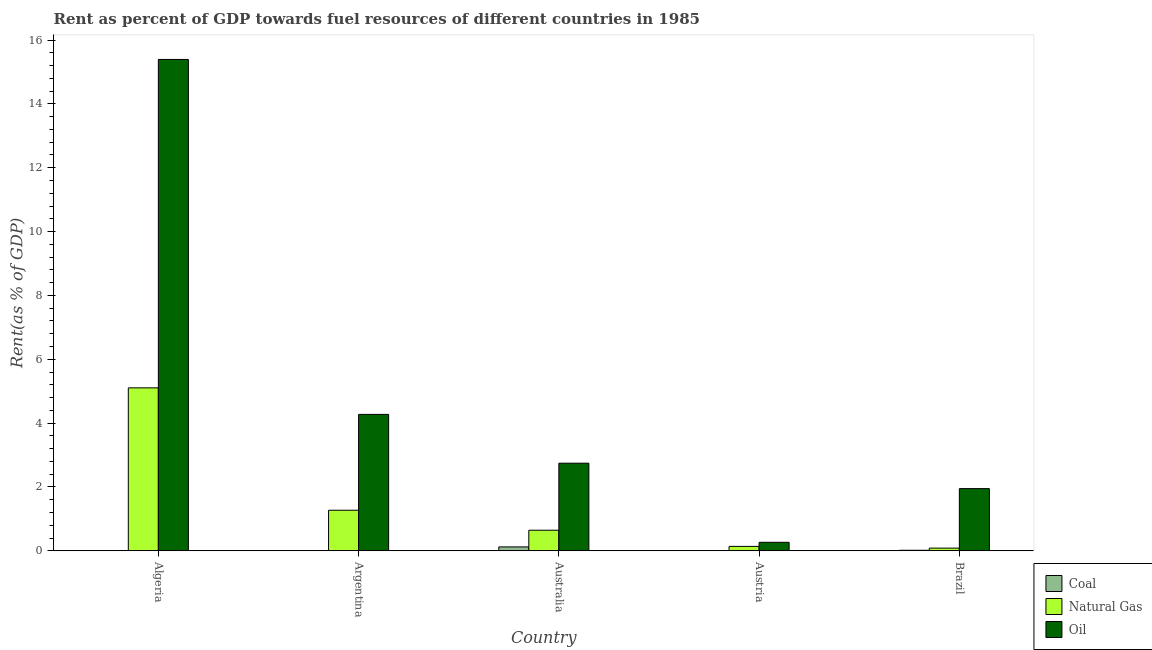How many different coloured bars are there?
Make the answer very short. 3. How many groups of bars are there?
Give a very brief answer. 5. Are the number of bars per tick equal to the number of legend labels?
Your response must be concise. Yes. How many bars are there on the 5th tick from the left?
Provide a short and direct response. 3. What is the rent towards natural gas in Algeria?
Offer a terse response. 5.1. Across all countries, what is the maximum rent towards natural gas?
Ensure brevity in your answer.  5.1. Across all countries, what is the minimum rent towards oil?
Make the answer very short. 0.27. In which country was the rent towards coal maximum?
Give a very brief answer. Australia. In which country was the rent towards coal minimum?
Your response must be concise. Algeria. What is the total rent towards coal in the graph?
Provide a succinct answer. 0.14. What is the difference between the rent towards oil in Argentina and that in Australia?
Offer a terse response. 1.53. What is the difference between the rent towards coal in Argentina and the rent towards natural gas in Brazil?
Provide a succinct answer. -0.08. What is the average rent towards coal per country?
Ensure brevity in your answer.  0.03. What is the difference between the rent towards coal and rent towards oil in Australia?
Give a very brief answer. -2.62. What is the ratio of the rent towards natural gas in Argentina to that in Brazil?
Make the answer very short. 15.24. Is the rent towards oil in Argentina less than that in Austria?
Offer a very short reply. No. Is the difference between the rent towards natural gas in Australia and Brazil greater than the difference between the rent towards oil in Australia and Brazil?
Provide a succinct answer. No. What is the difference between the highest and the second highest rent towards coal?
Your answer should be compact. 0.11. What is the difference between the highest and the lowest rent towards coal?
Your answer should be very brief. 0.12. In how many countries, is the rent towards coal greater than the average rent towards coal taken over all countries?
Your response must be concise. 1. What does the 1st bar from the left in Argentina represents?
Give a very brief answer. Coal. What does the 2nd bar from the right in Argentina represents?
Provide a succinct answer. Natural Gas. Is it the case that in every country, the sum of the rent towards coal and rent towards natural gas is greater than the rent towards oil?
Provide a succinct answer. No. How many countries are there in the graph?
Provide a short and direct response. 5. What is the difference between two consecutive major ticks on the Y-axis?
Your answer should be compact. 2. Does the graph contain any zero values?
Give a very brief answer. No. Does the graph contain grids?
Your response must be concise. No. Where does the legend appear in the graph?
Ensure brevity in your answer.  Bottom right. What is the title of the graph?
Your answer should be compact. Rent as percent of GDP towards fuel resources of different countries in 1985. Does "Coal sources" appear as one of the legend labels in the graph?
Keep it short and to the point. No. What is the label or title of the Y-axis?
Offer a terse response. Rent(as % of GDP). What is the Rent(as % of GDP) of Coal in Algeria?
Provide a short and direct response. 0. What is the Rent(as % of GDP) of Natural Gas in Algeria?
Give a very brief answer. 5.1. What is the Rent(as % of GDP) of Oil in Algeria?
Ensure brevity in your answer.  15.39. What is the Rent(as % of GDP) in Coal in Argentina?
Your response must be concise. 0. What is the Rent(as % of GDP) in Natural Gas in Argentina?
Your answer should be compact. 1.27. What is the Rent(as % of GDP) in Oil in Argentina?
Offer a terse response. 4.27. What is the Rent(as % of GDP) of Coal in Australia?
Provide a short and direct response. 0.12. What is the Rent(as % of GDP) of Natural Gas in Australia?
Your answer should be compact. 0.64. What is the Rent(as % of GDP) of Oil in Australia?
Your answer should be compact. 2.74. What is the Rent(as % of GDP) in Coal in Austria?
Your answer should be very brief. 0.01. What is the Rent(as % of GDP) in Natural Gas in Austria?
Make the answer very short. 0.14. What is the Rent(as % of GDP) in Oil in Austria?
Provide a short and direct response. 0.27. What is the Rent(as % of GDP) in Coal in Brazil?
Your answer should be compact. 0.02. What is the Rent(as % of GDP) in Natural Gas in Brazil?
Offer a terse response. 0.08. What is the Rent(as % of GDP) in Oil in Brazil?
Offer a very short reply. 1.95. Across all countries, what is the maximum Rent(as % of GDP) of Coal?
Your response must be concise. 0.12. Across all countries, what is the maximum Rent(as % of GDP) in Natural Gas?
Make the answer very short. 5.1. Across all countries, what is the maximum Rent(as % of GDP) in Oil?
Your answer should be compact. 15.39. Across all countries, what is the minimum Rent(as % of GDP) in Coal?
Give a very brief answer. 0. Across all countries, what is the minimum Rent(as % of GDP) in Natural Gas?
Provide a succinct answer. 0.08. Across all countries, what is the minimum Rent(as % of GDP) in Oil?
Keep it short and to the point. 0.27. What is the total Rent(as % of GDP) in Coal in the graph?
Give a very brief answer. 0.14. What is the total Rent(as % of GDP) of Natural Gas in the graph?
Make the answer very short. 7.24. What is the total Rent(as % of GDP) in Oil in the graph?
Provide a short and direct response. 24.62. What is the difference between the Rent(as % of GDP) of Coal in Algeria and that in Argentina?
Make the answer very short. -0. What is the difference between the Rent(as % of GDP) of Natural Gas in Algeria and that in Argentina?
Provide a short and direct response. 3.83. What is the difference between the Rent(as % of GDP) of Oil in Algeria and that in Argentina?
Make the answer very short. 11.12. What is the difference between the Rent(as % of GDP) in Coal in Algeria and that in Australia?
Your answer should be very brief. -0.12. What is the difference between the Rent(as % of GDP) of Natural Gas in Algeria and that in Australia?
Give a very brief answer. 4.46. What is the difference between the Rent(as % of GDP) of Oil in Algeria and that in Australia?
Provide a succinct answer. 12.65. What is the difference between the Rent(as % of GDP) of Coal in Algeria and that in Austria?
Provide a short and direct response. -0.01. What is the difference between the Rent(as % of GDP) of Natural Gas in Algeria and that in Austria?
Offer a very short reply. 4.97. What is the difference between the Rent(as % of GDP) in Oil in Algeria and that in Austria?
Offer a very short reply. 15.13. What is the difference between the Rent(as % of GDP) of Coal in Algeria and that in Brazil?
Keep it short and to the point. -0.02. What is the difference between the Rent(as % of GDP) of Natural Gas in Algeria and that in Brazil?
Your response must be concise. 5.02. What is the difference between the Rent(as % of GDP) of Oil in Algeria and that in Brazil?
Keep it short and to the point. 13.45. What is the difference between the Rent(as % of GDP) of Coal in Argentina and that in Australia?
Your answer should be compact. -0.12. What is the difference between the Rent(as % of GDP) of Natural Gas in Argentina and that in Australia?
Your response must be concise. 0.63. What is the difference between the Rent(as % of GDP) of Oil in Argentina and that in Australia?
Your response must be concise. 1.53. What is the difference between the Rent(as % of GDP) of Coal in Argentina and that in Austria?
Give a very brief answer. -0. What is the difference between the Rent(as % of GDP) of Natural Gas in Argentina and that in Austria?
Offer a very short reply. 1.13. What is the difference between the Rent(as % of GDP) in Oil in Argentina and that in Austria?
Your response must be concise. 4.01. What is the difference between the Rent(as % of GDP) of Coal in Argentina and that in Brazil?
Provide a short and direct response. -0.01. What is the difference between the Rent(as % of GDP) in Natural Gas in Argentina and that in Brazil?
Give a very brief answer. 1.19. What is the difference between the Rent(as % of GDP) of Oil in Argentina and that in Brazil?
Your response must be concise. 2.33. What is the difference between the Rent(as % of GDP) of Coal in Australia and that in Austria?
Your answer should be compact. 0.12. What is the difference between the Rent(as % of GDP) in Natural Gas in Australia and that in Austria?
Keep it short and to the point. 0.51. What is the difference between the Rent(as % of GDP) in Oil in Australia and that in Austria?
Your response must be concise. 2.48. What is the difference between the Rent(as % of GDP) of Coal in Australia and that in Brazil?
Keep it short and to the point. 0.11. What is the difference between the Rent(as % of GDP) in Natural Gas in Australia and that in Brazil?
Make the answer very short. 0.56. What is the difference between the Rent(as % of GDP) in Oil in Australia and that in Brazil?
Provide a succinct answer. 0.8. What is the difference between the Rent(as % of GDP) of Coal in Austria and that in Brazil?
Give a very brief answer. -0.01. What is the difference between the Rent(as % of GDP) in Natural Gas in Austria and that in Brazil?
Offer a very short reply. 0.05. What is the difference between the Rent(as % of GDP) of Oil in Austria and that in Brazil?
Offer a very short reply. -1.68. What is the difference between the Rent(as % of GDP) of Coal in Algeria and the Rent(as % of GDP) of Natural Gas in Argentina?
Provide a short and direct response. -1.27. What is the difference between the Rent(as % of GDP) in Coal in Algeria and the Rent(as % of GDP) in Oil in Argentina?
Your answer should be compact. -4.27. What is the difference between the Rent(as % of GDP) in Natural Gas in Algeria and the Rent(as % of GDP) in Oil in Argentina?
Your answer should be compact. 0.83. What is the difference between the Rent(as % of GDP) of Coal in Algeria and the Rent(as % of GDP) of Natural Gas in Australia?
Your answer should be compact. -0.64. What is the difference between the Rent(as % of GDP) in Coal in Algeria and the Rent(as % of GDP) in Oil in Australia?
Give a very brief answer. -2.74. What is the difference between the Rent(as % of GDP) of Natural Gas in Algeria and the Rent(as % of GDP) of Oil in Australia?
Make the answer very short. 2.36. What is the difference between the Rent(as % of GDP) in Coal in Algeria and the Rent(as % of GDP) in Natural Gas in Austria?
Your answer should be very brief. -0.14. What is the difference between the Rent(as % of GDP) of Coal in Algeria and the Rent(as % of GDP) of Oil in Austria?
Your answer should be compact. -0.27. What is the difference between the Rent(as % of GDP) of Natural Gas in Algeria and the Rent(as % of GDP) of Oil in Austria?
Give a very brief answer. 4.84. What is the difference between the Rent(as % of GDP) of Coal in Algeria and the Rent(as % of GDP) of Natural Gas in Brazil?
Offer a very short reply. -0.08. What is the difference between the Rent(as % of GDP) in Coal in Algeria and the Rent(as % of GDP) in Oil in Brazil?
Provide a short and direct response. -1.95. What is the difference between the Rent(as % of GDP) in Natural Gas in Algeria and the Rent(as % of GDP) in Oil in Brazil?
Offer a terse response. 3.16. What is the difference between the Rent(as % of GDP) in Coal in Argentina and the Rent(as % of GDP) in Natural Gas in Australia?
Make the answer very short. -0.64. What is the difference between the Rent(as % of GDP) in Coal in Argentina and the Rent(as % of GDP) in Oil in Australia?
Offer a terse response. -2.74. What is the difference between the Rent(as % of GDP) of Natural Gas in Argentina and the Rent(as % of GDP) of Oil in Australia?
Your answer should be compact. -1.47. What is the difference between the Rent(as % of GDP) of Coal in Argentina and the Rent(as % of GDP) of Natural Gas in Austria?
Offer a very short reply. -0.14. What is the difference between the Rent(as % of GDP) in Coal in Argentina and the Rent(as % of GDP) in Oil in Austria?
Provide a short and direct response. -0.26. What is the difference between the Rent(as % of GDP) in Natural Gas in Argentina and the Rent(as % of GDP) in Oil in Austria?
Offer a very short reply. 1. What is the difference between the Rent(as % of GDP) of Coal in Argentina and the Rent(as % of GDP) of Natural Gas in Brazil?
Give a very brief answer. -0.08. What is the difference between the Rent(as % of GDP) of Coal in Argentina and the Rent(as % of GDP) of Oil in Brazil?
Give a very brief answer. -1.95. What is the difference between the Rent(as % of GDP) in Natural Gas in Argentina and the Rent(as % of GDP) in Oil in Brazil?
Provide a succinct answer. -0.68. What is the difference between the Rent(as % of GDP) of Coal in Australia and the Rent(as % of GDP) of Natural Gas in Austria?
Offer a terse response. -0.02. What is the difference between the Rent(as % of GDP) in Coal in Australia and the Rent(as % of GDP) in Oil in Austria?
Offer a very short reply. -0.14. What is the difference between the Rent(as % of GDP) in Natural Gas in Australia and the Rent(as % of GDP) in Oil in Austria?
Offer a terse response. 0.38. What is the difference between the Rent(as % of GDP) in Coal in Australia and the Rent(as % of GDP) in Natural Gas in Brazil?
Keep it short and to the point. 0.04. What is the difference between the Rent(as % of GDP) in Coal in Australia and the Rent(as % of GDP) in Oil in Brazil?
Keep it short and to the point. -1.83. What is the difference between the Rent(as % of GDP) of Natural Gas in Australia and the Rent(as % of GDP) of Oil in Brazil?
Your answer should be compact. -1.3. What is the difference between the Rent(as % of GDP) in Coal in Austria and the Rent(as % of GDP) in Natural Gas in Brazil?
Your answer should be compact. -0.08. What is the difference between the Rent(as % of GDP) of Coal in Austria and the Rent(as % of GDP) of Oil in Brazil?
Provide a short and direct response. -1.94. What is the difference between the Rent(as % of GDP) in Natural Gas in Austria and the Rent(as % of GDP) in Oil in Brazil?
Offer a terse response. -1.81. What is the average Rent(as % of GDP) of Coal per country?
Give a very brief answer. 0.03. What is the average Rent(as % of GDP) in Natural Gas per country?
Make the answer very short. 1.45. What is the average Rent(as % of GDP) in Oil per country?
Ensure brevity in your answer.  4.92. What is the difference between the Rent(as % of GDP) in Coal and Rent(as % of GDP) in Natural Gas in Algeria?
Your response must be concise. -5.1. What is the difference between the Rent(as % of GDP) of Coal and Rent(as % of GDP) of Oil in Algeria?
Keep it short and to the point. -15.39. What is the difference between the Rent(as % of GDP) of Natural Gas and Rent(as % of GDP) of Oil in Algeria?
Your answer should be very brief. -10.29. What is the difference between the Rent(as % of GDP) of Coal and Rent(as % of GDP) of Natural Gas in Argentina?
Your response must be concise. -1.27. What is the difference between the Rent(as % of GDP) in Coal and Rent(as % of GDP) in Oil in Argentina?
Offer a terse response. -4.27. What is the difference between the Rent(as % of GDP) in Natural Gas and Rent(as % of GDP) in Oil in Argentina?
Give a very brief answer. -3. What is the difference between the Rent(as % of GDP) of Coal and Rent(as % of GDP) of Natural Gas in Australia?
Provide a succinct answer. -0.52. What is the difference between the Rent(as % of GDP) in Coal and Rent(as % of GDP) in Oil in Australia?
Make the answer very short. -2.62. What is the difference between the Rent(as % of GDP) in Natural Gas and Rent(as % of GDP) in Oil in Australia?
Ensure brevity in your answer.  -2.1. What is the difference between the Rent(as % of GDP) in Coal and Rent(as % of GDP) in Natural Gas in Austria?
Keep it short and to the point. -0.13. What is the difference between the Rent(as % of GDP) in Coal and Rent(as % of GDP) in Oil in Austria?
Your response must be concise. -0.26. What is the difference between the Rent(as % of GDP) of Natural Gas and Rent(as % of GDP) of Oil in Austria?
Your answer should be very brief. -0.13. What is the difference between the Rent(as % of GDP) of Coal and Rent(as % of GDP) of Natural Gas in Brazil?
Your answer should be very brief. -0.07. What is the difference between the Rent(as % of GDP) of Coal and Rent(as % of GDP) of Oil in Brazil?
Make the answer very short. -1.93. What is the difference between the Rent(as % of GDP) of Natural Gas and Rent(as % of GDP) of Oil in Brazil?
Your response must be concise. -1.86. What is the ratio of the Rent(as % of GDP) in Coal in Algeria to that in Argentina?
Your answer should be compact. 0.14. What is the ratio of the Rent(as % of GDP) in Natural Gas in Algeria to that in Argentina?
Keep it short and to the point. 4.02. What is the ratio of the Rent(as % of GDP) in Oil in Algeria to that in Argentina?
Provide a short and direct response. 3.6. What is the ratio of the Rent(as % of GDP) in Coal in Algeria to that in Australia?
Make the answer very short. 0. What is the ratio of the Rent(as % of GDP) in Natural Gas in Algeria to that in Australia?
Provide a short and direct response. 7.93. What is the ratio of the Rent(as % of GDP) of Oil in Algeria to that in Australia?
Provide a short and direct response. 5.61. What is the ratio of the Rent(as % of GDP) of Coal in Algeria to that in Austria?
Make the answer very short. 0.02. What is the ratio of the Rent(as % of GDP) of Natural Gas in Algeria to that in Austria?
Offer a very short reply. 37.04. What is the ratio of the Rent(as % of GDP) of Oil in Algeria to that in Austria?
Ensure brevity in your answer.  58.01. What is the ratio of the Rent(as % of GDP) in Coal in Algeria to that in Brazil?
Keep it short and to the point. 0.01. What is the ratio of the Rent(as % of GDP) of Natural Gas in Algeria to that in Brazil?
Keep it short and to the point. 61.26. What is the ratio of the Rent(as % of GDP) of Oil in Algeria to that in Brazil?
Your answer should be compact. 7.91. What is the ratio of the Rent(as % of GDP) in Coal in Argentina to that in Australia?
Provide a short and direct response. 0.01. What is the ratio of the Rent(as % of GDP) in Natural Gas in Argentina to that in Australia?
Your answer should be very brief. 1.97. What is the ratio of the Rent(as % of GDP) in Oil in Argentina to that in Australia?
Give a very brief answer. 1.56. What is the ratio of the Rent(as % of GDP) of Coal in Argentina to that in Austria?
Offer a terse response. 0.15. What is the ratio of the Rent(as % of GDP) in Natural Gas in Argentina to that in Austria?
Ensure brevity in your answer.  9.21. What is the ratio of the Rent(as % of GDP) of Oil in Argentina to that in Austria?
Give a very brief answer. 16.1. What is the ratio of the Rent(as % of GDP) in Coal in Argentina to that in Brazil?
Make the answer very short. 0.05. What is the ratio of the Rent(as % of GDP) in Natural Gas in Argentina to that in Brazil?
Offer a very short reply. 15.24. What is the ratio of the Rent(as % of GDP) of Oil in Argentina to that in Brazil?
Make the answer very short. 2.19. What is the ratio of the Rent(as % of GDP) in Coal in Australia to that in Austria?
Offer a terse response. 23.09. What is the ratio of the Rent(as % of GDP) of Natural Gas in Australia to that in Austria?
Provide a succinct answer. 4.67. What is the ratio of the Rent(as % of GDP) in Oil in Australia to that in Austria?
Offer a terse response. 10.34. What is the ratio of the Rent(as % of GDP) in Coal in Australia to that in Brazil?
Provide a succinct answer. 7.73. What is the ratio of the Rent(as % of GDP) in Natural Gas in Australia to that in Brazil?
Make the answer very short. 7.73. What is the ratio of the Rent(as % of GDP) of Oil in Australia to that in Brazil?
Provide a short and direct response. 1.41. What is the ratio of the Rent(as % of GDP) of Coal in Austria to that in Brazil?
Your answer should be very brief. 0.34. What is the ratio of the Rent(as % of GDP) of Natural Gas in Austria to that in Brazil?
Keep it short and to the point. 1.65. What is the ratio of the Rent(as % of GDP) in Oil in Austria to that in Brazil?
Your response must be concise. 0.14. What is the difference between the highest and the second highest Rent(as % of GDP) of Coal?
Make the answer very short. 0.11. What is the difference between the highest and the second highest Rent(as % of GDP) in Natural Gas?
Provide a succinct answer. 3.83. What is the difference between the highest and the second highest Rent(as % of GDP) in Oil?
Your response must be concise. 11.12. What is the difference between the highest and the lowest Rent(as % of GDP) in Coal?
Provide a succinct answer. 0.12. What is the difference between the highest and the lowest Rent(as % of GDP) of Natural Gas?
Offer a terse response. 5.02. What is the difference between the highest and the lowest Rent(as % of GDP) of Oil?
Give a very brief answer. 15.13. 